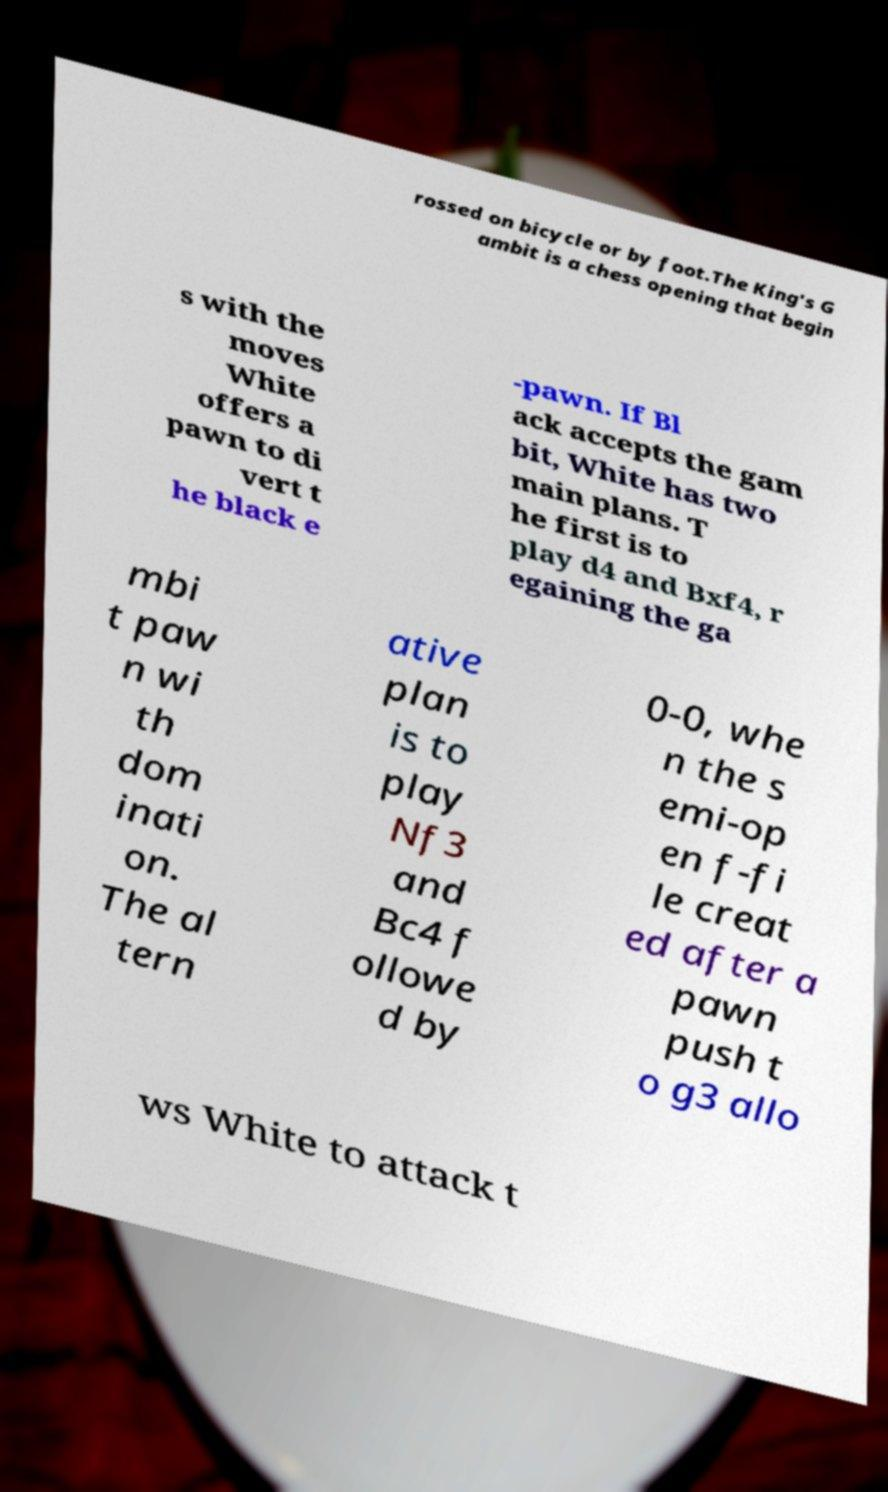I need the written content from this picture converted into text. Can you do that? rossed on bicycle or by foot.The King's G ambit is a chess opening that begin s with the moves White offers a pawn to di vert t he black e -pawn. If Bl ack accepts the gam bit, White has two main plans. T he first is to play d4 and Bxf4, r egaining the ga mbi t paw n wi th dom inati on. The al tern ative plan is to play Nf3 and Bc4 f ollowe d by 0-0, whe n the s emi-op en f-fi le creat ed after a pawn push t o g3 allo ws White to attack t 